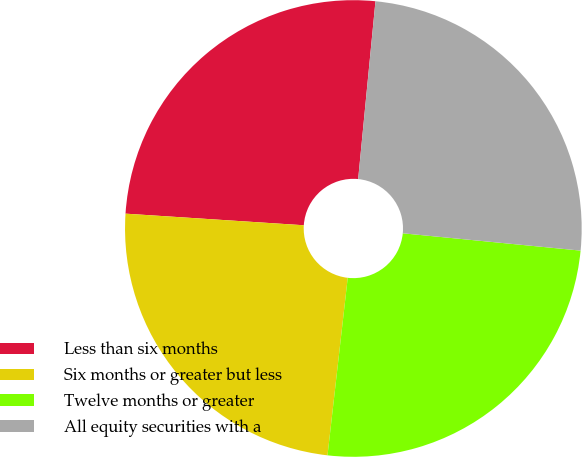Convert chart to OTSL. <chart><loc_0><loc_0><loc_500><loc_500><pie_chart><fcel>Less than six months<fcel>Six months or greater but less<fcel>Twelve months or greater<fcel>All equity securities with a<nl><fcel>25.51%<fcel>24.23%<fcel>25.26%<fcel>25.0%<nl></chart> 